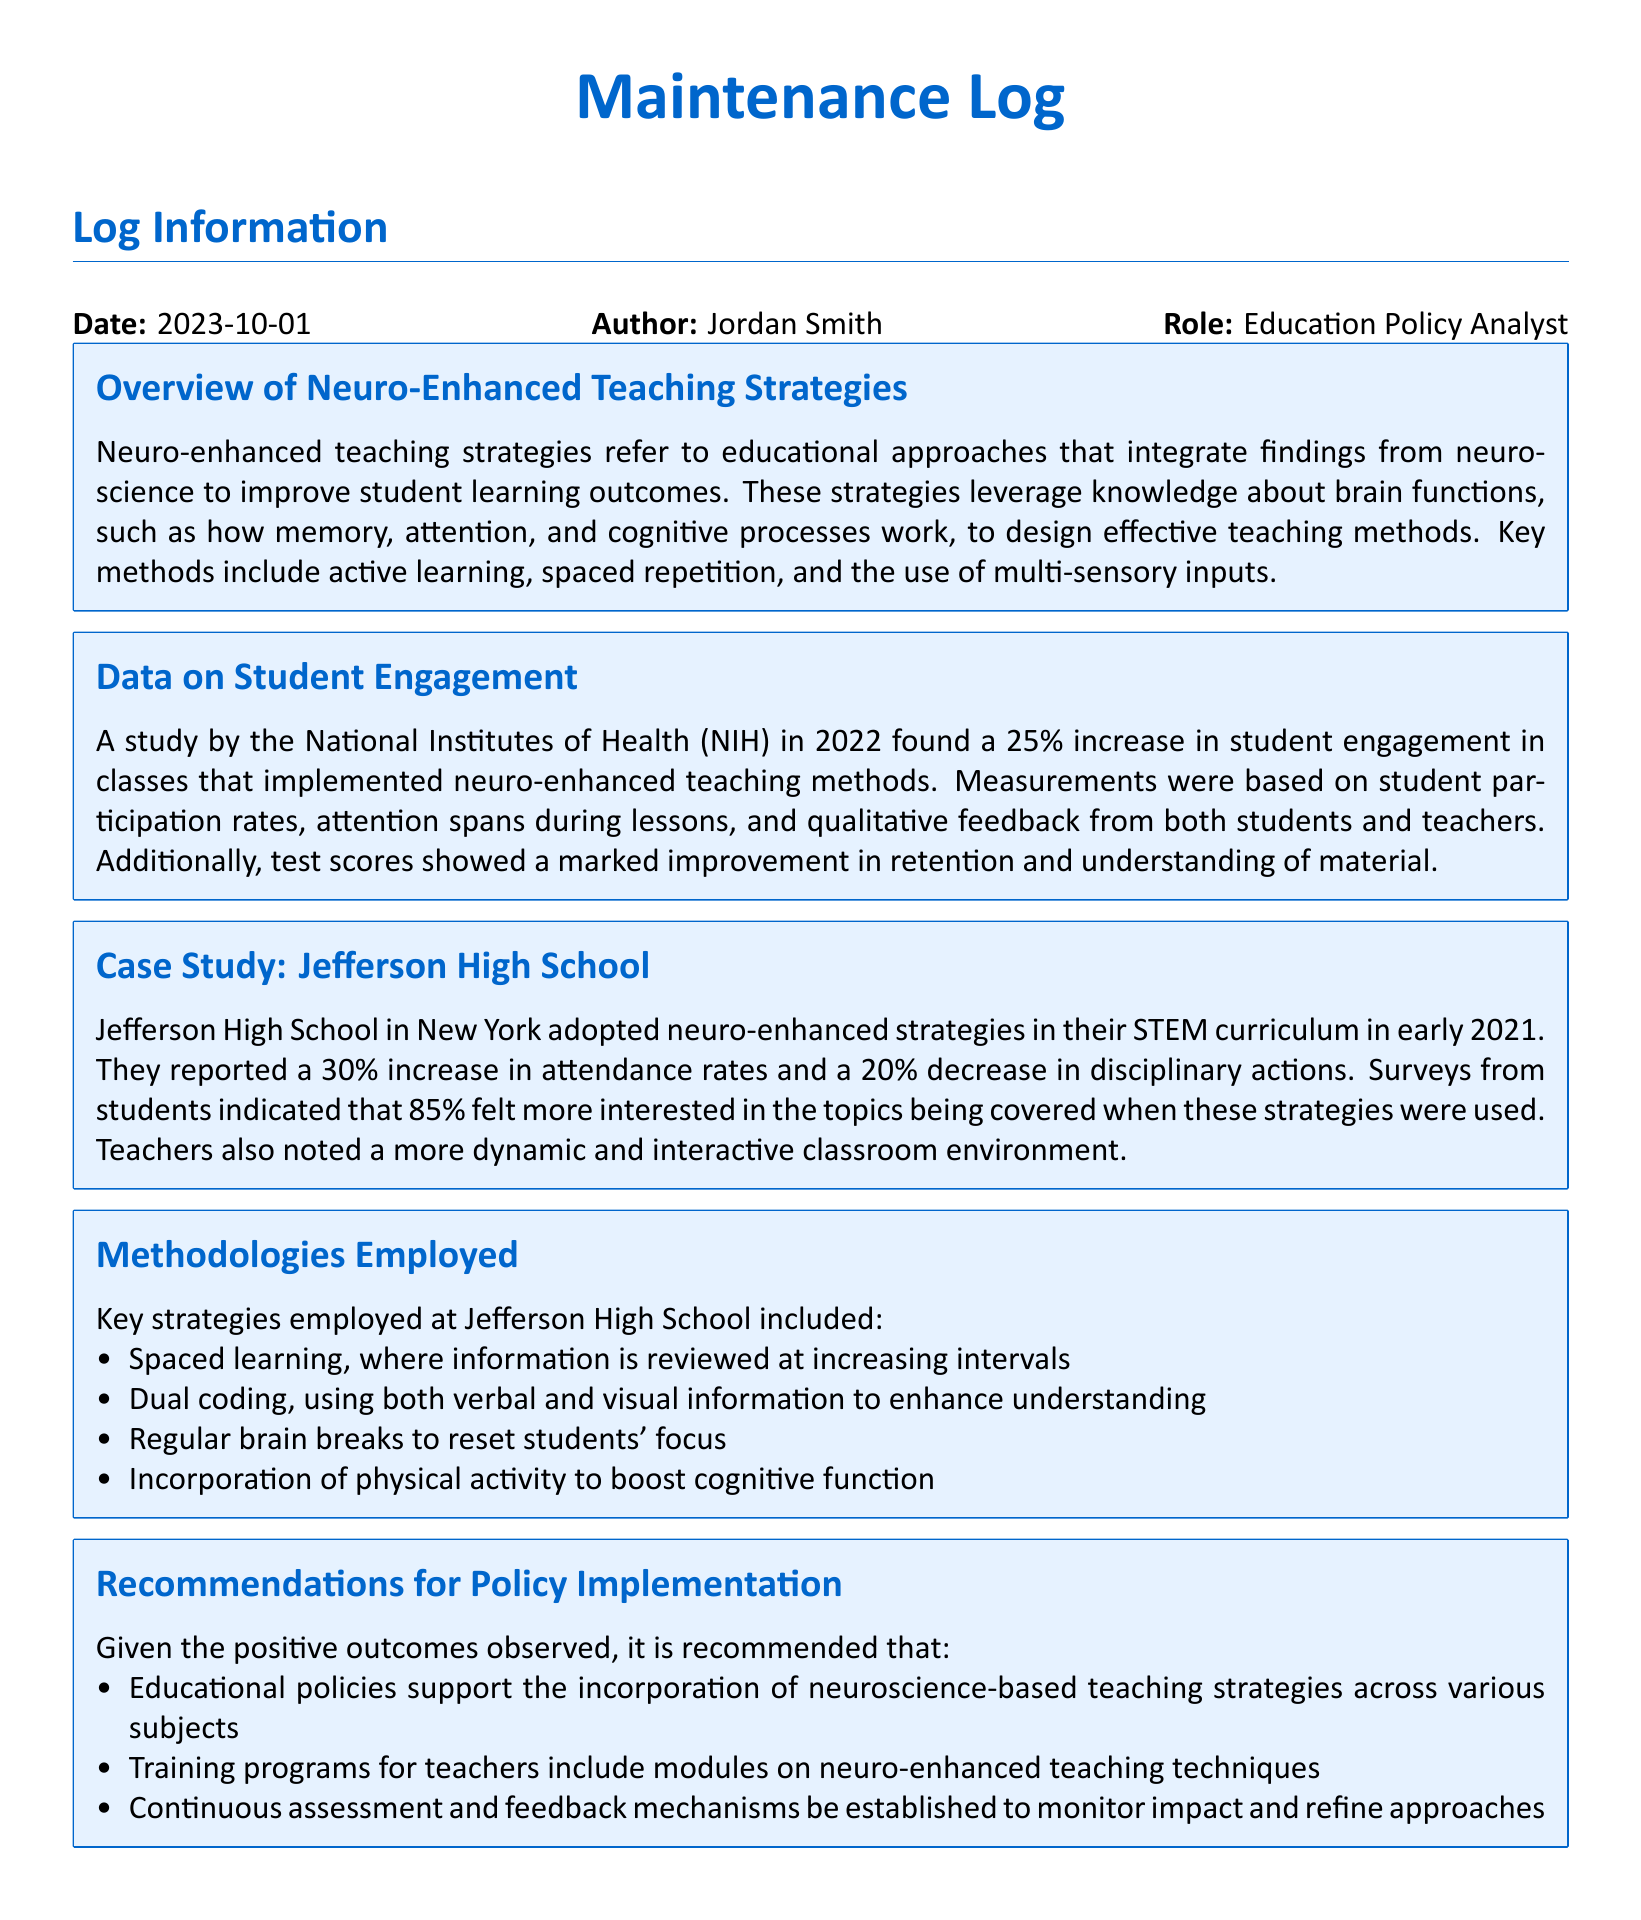What is the date of the log? The date of the log is mentioned in the "Log Information" section.
Answer: 2023-10-01 Who is the author of the log? The author's name is included in the "Log Information" section.
Answer: Jordan Smith What is one of the key methodologies employed at Jefferson High School? This information can be found in the "Methodologies Employed" section detailing specific teaching strategies.
Answer: Spaced learning What percentage increase in attendance rates was reported by Jefferson High School? This figure is found in the "Case Study: Jefferson High School" section.
Answer: 30% What organization conducted the study on student engagement? The organization responsible for the study is specified in the "Data on Student Engagement" section.
Answer: National Institutes of Health According to the log, what percentage of students felt more interested in the topics? This statistic is provided in the "Case Study: Jefferson High School" section.
Answer: 85% What recommendation is made regarding teacher training? The recommendations for teacher training are listed in the "Recommendations for Policy Implementation" section.
Answer: Include modules on neuro-enhanced teaching techniques What was the percentage increase in student engagement reported in the study? This statistic is drawn from the "Data on Student Engagement" section.
Answer: 25% What are "brain breaks"? The explanation of brain breaks can be inferred from the "Methodologies Employed" section related to resetting focus.
Answer: Regular breaks to reset focus Which curriculum area did Jefferson High School implement neuro-enhanced strategies? The specific curriculum area is mentioned in the "Case Study: Jefferson High School."
Answer: STEM curriculum 